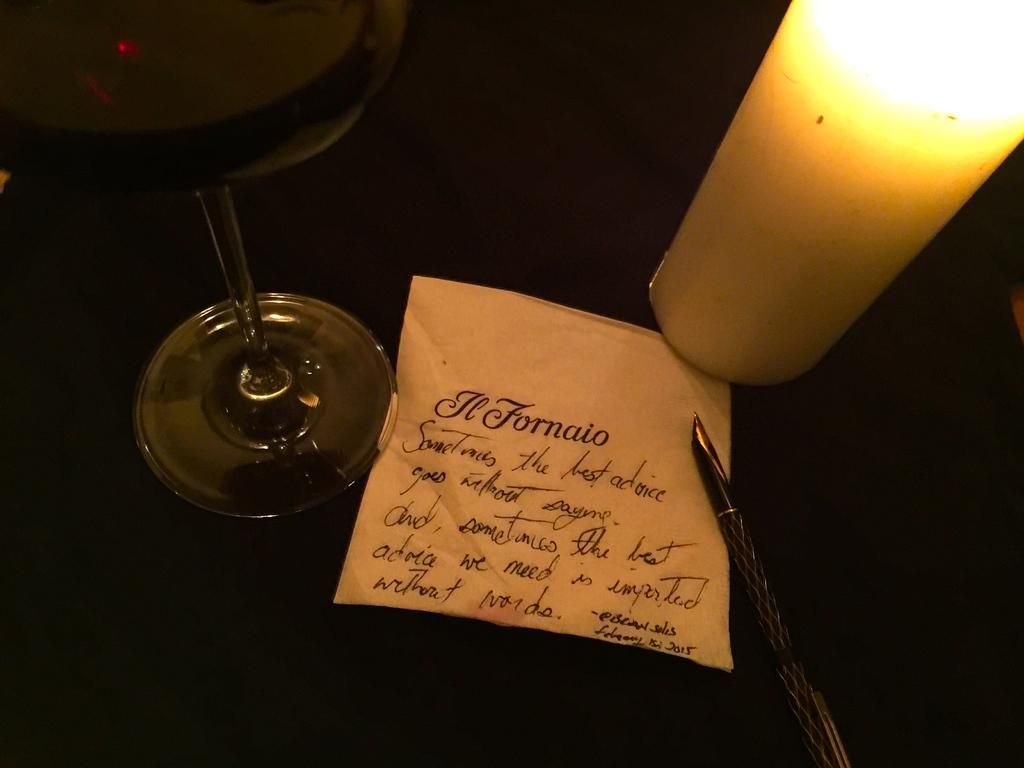What type of container is visible in the image? There is a glass in the image. What is the source of light in the image? There is a candle in the image. What writing instrument is present in the image? There is a pen in the image. What is the pen resting on in the image? There is a note in the image. What is the color of the surface the objects are on? The surface the objects are on is black in color. How many worms can be seen crawling on the pen in the image? There are no worms present in the image; the pen is resting on a note. What type of clock is visible on the black surface in the image? There is no clock present in the image; only a glass, candle, pen, and note are visible. 